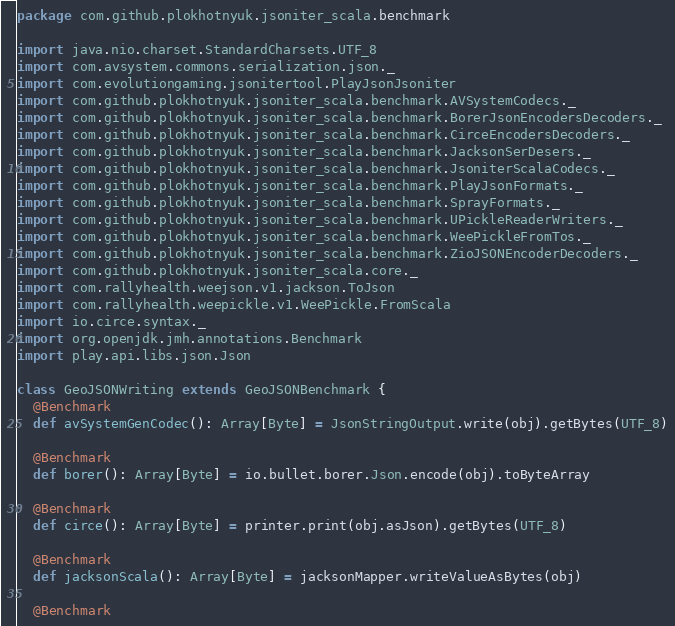<code> <loc_0><loc_0><loc_500><loc_500><_Scala_>package com.github.plokhotnyuk.jsoniter_scala.benchmark

import java.nio.charset.StandardCharsets.UTF_8
import com.avsystem.commons.serialization.json._
import com.evolutiongaming.jsonitertool.PlayJsonJsoniter
import com.github.plokhotnyuk.jsoniter_scala.benchmark.AVSystemCodecs._
import com.github.plokhotnyuk.jsoniter_scala.benchmark.BorerJsonEncodersDecoders._
import com.github.plokhotnyuk.jsoniter_scala.benchmark.CirceEncodersDecoders._
import com.github.plokhotnyuk.jsoniter_scala.benchmark.JacksonSerDesers._
import com.github.plokhotnyuk.jsoniter_scala.benchmark.JsoniterScalaCodecs._
import com.github.plokhotnyuk.jsoniter_scala.benchmark.PlayJsonFormats._
import com.github.plokhotnyuk.jsoniter_scala.benchmark.SprayFormats._
import com.github.plokhotnyuk.jsoniter_scala.benchmark.UPickleReaderWriters._
import com.github.plokhotnyuk.jsoniter_scala.benchmark.WeePickleFromTos._
import com.github.plokhotnyuk.jsoniter_scala.benchmark.ZioJSONEncoderDecoders._
import com.github.plokhotnyuk.jsoniter_scala.core._
import com.rallyhealth.weejson.v1.jackson.ToJson
import com.rallyhealth.weepickle.v1.WeePickle.FromScala
import io.circe.syntax._
import org.openjdk.jmh.annotations.Benchmark
import play.api.libs.json.Json

class GeoJSONWriting extends GeoJSONBenchmark {
  @Benchmark
  def avSystemGenCodec(): Array[Byte] = JsonStringOutput.write(obj).getBytes(UTF_8)

  @Benchmark
  def borer(): Array[Byte] = io.bullet.borer.Json.encode(obj).toByteArray

  @Benchmark
  def circe(): Array[Byte] = printer.print(obj.asJson).getBytes(UTF_8)

  @Benchmark
  def jacksonScala(): Array[Byte] = jacksonMapper.writeValueAsBytes(obj)

  @Benchmark</code> 